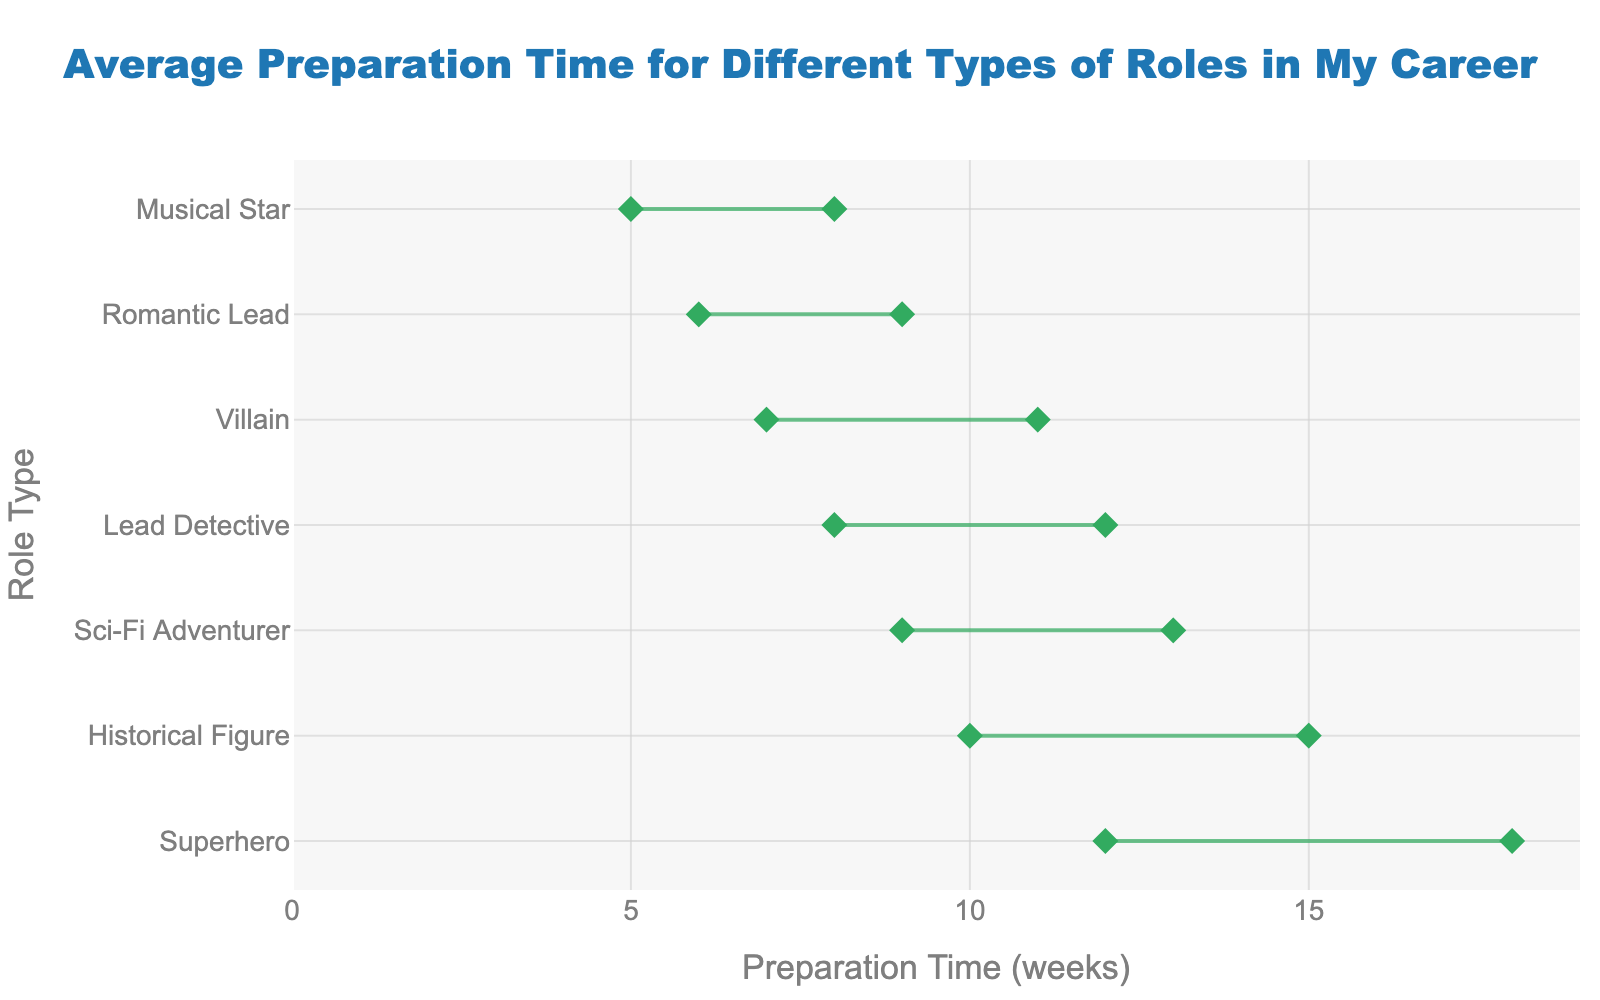What's the title of the figure? The title is located at the top of the figure and reads "Average Preparation Time for Different Types of Roles in My Career".
Answer: Average Preparation Time for Different Types of Roles in My Career Which role has the highest maximum preparation time? Look for the role with the highest endpoint on the x-axis, which represents the maximum preparation time. The highest maximum prep time is 18 weeks.
Answer: Superhero What’s the range of preparation time for the Musical Star role? To find this, look at the entry for Musical Star, noting the difference between the max and min preparation time values. The range is 8 - 5 weeks.
Answer: 3 weeks Which role has the smallest average preparation time? To find the smallest average, calculate the average for each role and identify the smallest. The Musical Star role has the smallest average (5+8)/2 = 6.5 weeks.
Answer: Musical Star How many roles require more than 10 weeks of preparation on average? Count the roles where the midpoint of the line (average of min and max prep time) is greater than 10 weeks. There are four such roles.
Answer: 4 roles Compare the maximum preparation times of the Lead Detective and Romantic Lead roles. Which one is higher? Find the endpoints on the x-axis for both roles. The Lead Detective’s max is 12, and the Romantic Lead’s is 9 weeks, so Lead Detective is higher.
Answer: Lead Detective What is the average preparation time for playing a Historical Figure? Average the min and max preparation times for the Historical Figure role: (10+15)/2.
Answer: 12.5 weeks Which role directed by Steven Spielberg is included in the figure? Look for the role associated with the film "The Kingdom's Rise", directed by Steven Spielberg.
Answer: Historical Figure What’s the difference in maximum preparation time between the Sci-Fi Adventurer and Villain roles? Subtract the maximum preparation time of the Villain from the Sci-Fi Adventurer: 13 - 11.
Answer: 2 weeks What's the role associated with the film "Dark Vendetta"? Find the role linked to the film "Dark Vendetta" in the figure.
Answer: Villain 